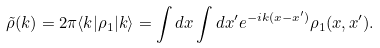<formula> <loc_0><loc_0><loc_500><loc_500>\tilde { \rho } ( k ) = 2 \pi \langle k | \rho _ { 1 } | k \rangle = \int d x \int d x ^ { \prime } e ^ { - i k ( x - x ^ { \prime } ) } \rho _ { 1 } ( x , x ^ { \prime } ) .</formula> 